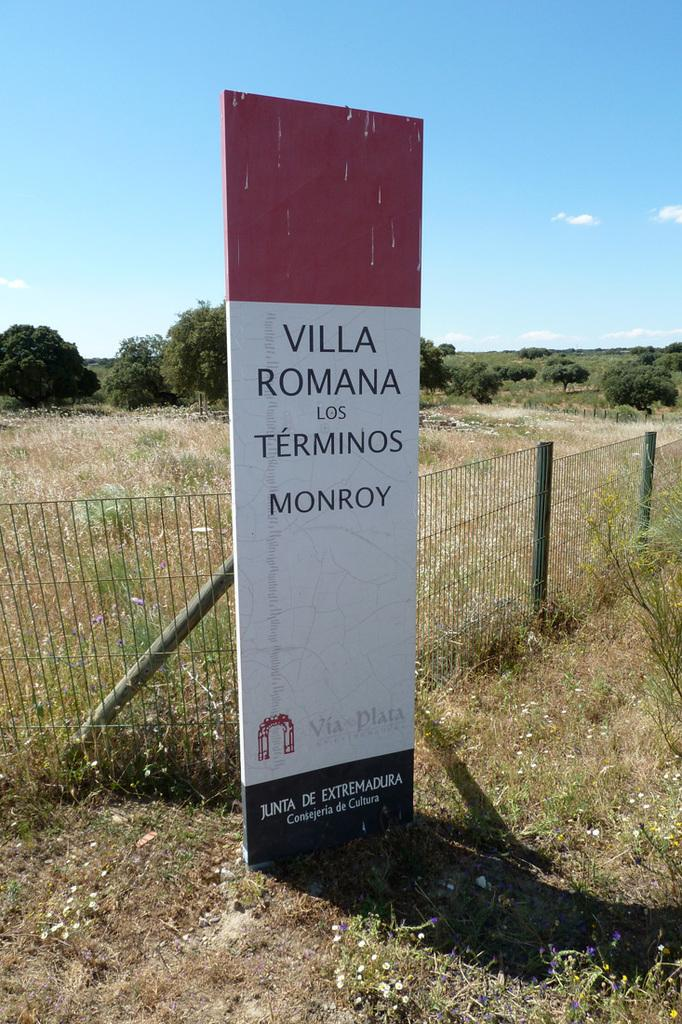What is near the fencing in the image? There is a banner near the fencing in the image. What can be seen in the background of the image? Farmland, trees, plants, and grass are visible in the background of the image. What is visible in the top right of the image? The sky is visible in the top right of the image. What can be observed in the sky? Clouds are present in the sky. What grade is the teacher writing on the chalkboard in the image? There is no chalkboard or teacher present in the image. How many chickens can be seen running around in the farmland in the image? There are no chickens visible in the image; only farmland, trees, plants, and grass can be seen in the background. 